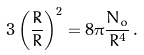Convert formula to latex. <formula><loc_0><loc_0><loc_500><loc_500>3 \left ( \frac { \dot { R } } { R } \right ) ^ { 2 } = 8 \pi \frac { N _ { o } } { R ^ { 4 } } \, .</formula> 